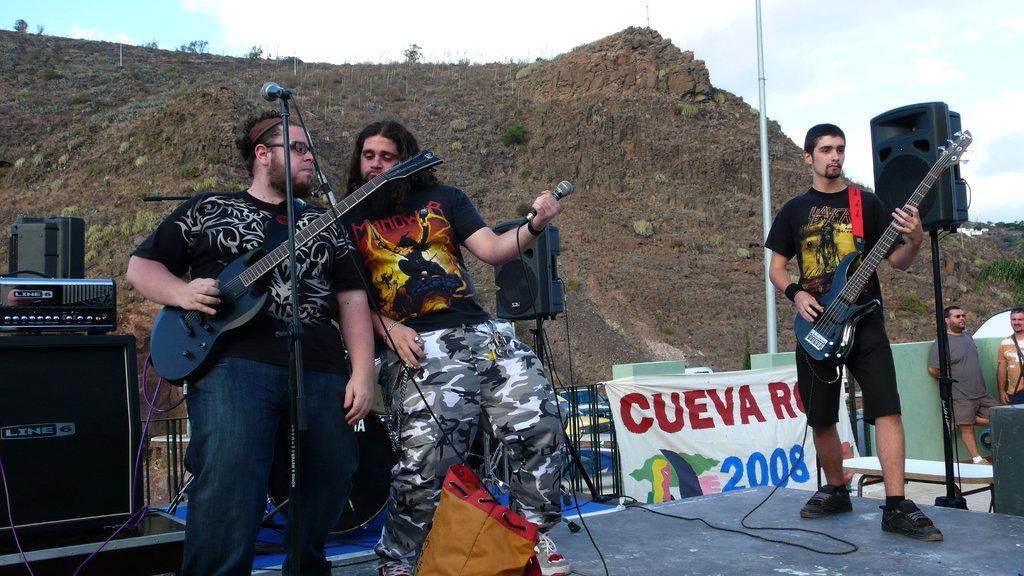Could you give a brief overview of what you see in this image? In this image we can see there are people. Among them two are holding guitars and one is holding a microphone. There are musical instruments. On the right there are people standing. There is a banner, pole and microphone. In the background we can see mountains and sky.   